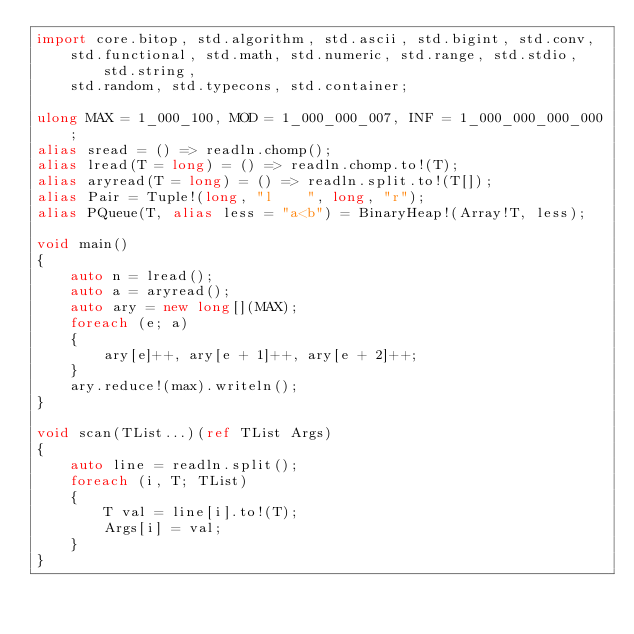<code> <loc_0><loc_0><loc_500><loc_500><_D_>import core.bitop, std.algorithm, std.ascii, std.bigint, std.conv,
    std.functional, std.math, std.numeric, std.range, std.stdio, std.string,
    std.random, std.typecons, std.container;

ulong MAX = 1_000_100, MOD = 1_000_000_007, INF = 1_000_000_000_000;
alias sread = () => readln.chomp();
alias lread(T = long) = () => readln.chomp.to!(T);
alias aryread(T = long) = () => readln.split.to!(T[]);
alias Pair = Tuple!(long, "l    ", long, "r");
alias PQueue(T, alias less = "a<b") = BinaryHeap!(Array!T, less);

void main()
{
    auto n = lread();
    auto a = aryread();
    auto ary = new long[](MAX);
    foreach (e; a)
    {
        ary[e]++, ary[e + 1]++, ary[e + 2]++;
    }
    ary.reduce!(max).writeln();
}

void scan(TList...)(ref TList Args)
{
    auto line = readln.split();
    foreach (i, T; TList)
    {
        T val = line[i].to!(T);
        Args[i] = val;
    }
}
</code> 